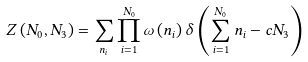Convert formula to latex. <formula><loc_0><loc_0><loc_500><loc_500>Z \left ( N _ { 0 } , N _ { 3 } \right ) = \sum _ { n _ { i } } \prod _ { i = 1 } ^ { N _ { 0 } } \omega \left ( n _ { i } \right ) \delta \left ( \sum _ { i = 1 } ^ { N _ { 0 } } n _ { i } - c N _ { 3 } \right )</formula> 